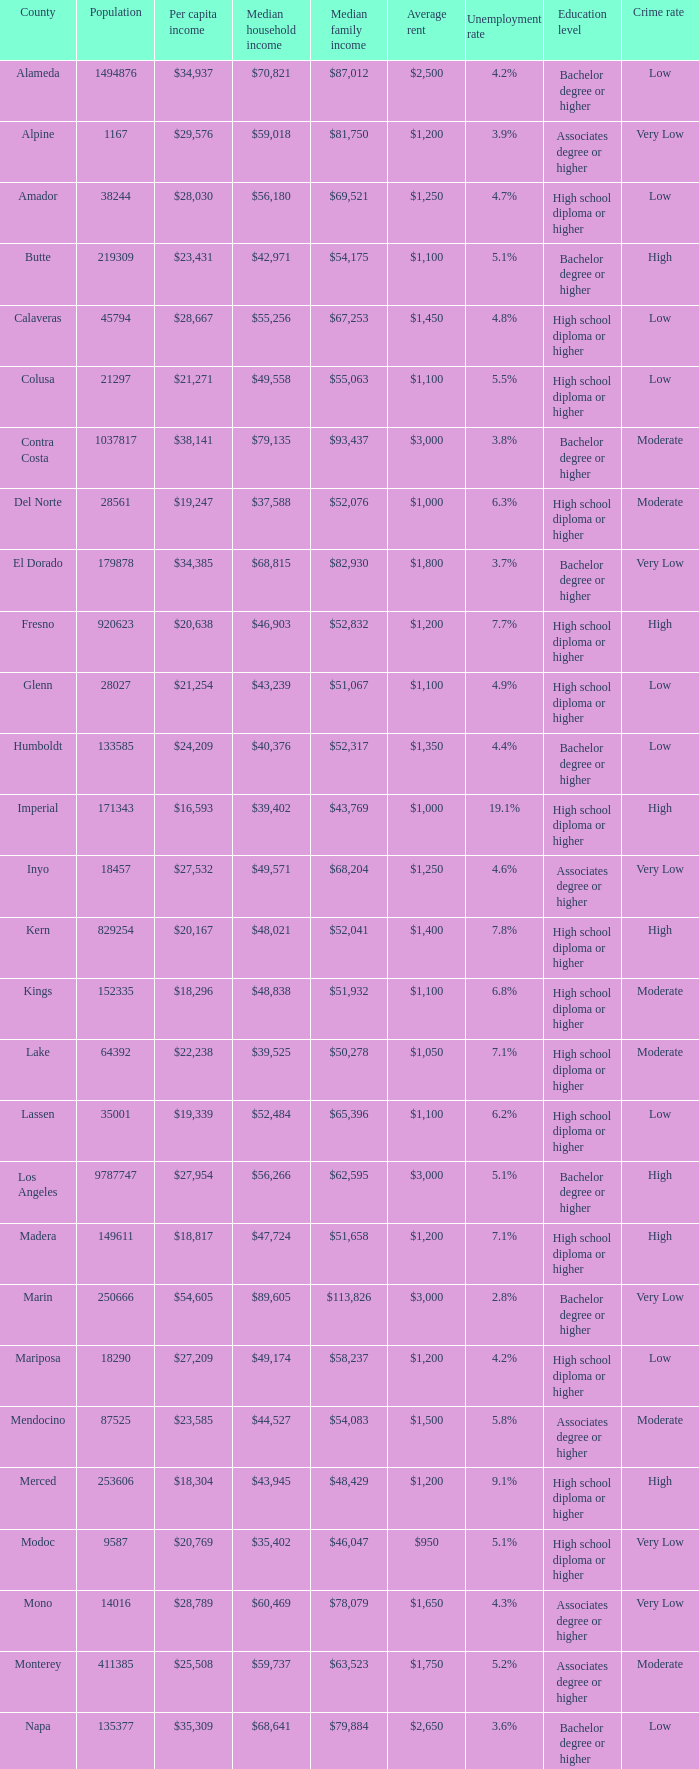Help me parse the entirety of this table. {'header': ['County', 'Population', 'Per capita income', 'Median household income', 'Median family income', 'Average rent', 'Unemployment rate', 'Education level', 'Crime rate '], 'rows': [['Alameda', '1494876', '$34,937', '$70,821', '$87,012', '$2,500', '4.2%', 'Bachelor degree or higher', 'Low'], ['Alpine', '1167', '$29,576', '$59,018', '$81,750', '$1,200', '3.9%', 'Associates degree or higher', 'Very Low'], ['Amador', '38244', '$28,030', '$56,180', '$69,521', '$1,250', '4.7%', 'High school diploma or higher', 'Low'], ['Butte', '219309', '$23,431', '$42,971', '$54,175', '$1,100', '5.1%', 'Bachelor degree or higher', 'High'], ['Calaveras', '45794', '$28,667', '$55,256', '$67,253', '$1,450', '4.8%', 'High school diploma or higher', 'Low'], ['Colusa', '21297', '$21,271', '$49,558', '$55,063', '$1,100', '5.5%', 'High school diploma or higher', 'Low'], ['Contra Costa', '1037817', '$38,141', '$79,135', '$93,437', '$3,000', '3.8%', 'Bachelor degree or higher', 'Moderate'], ['Del Norte', '28561', '$19,247', '$37,588', '$52,076', '$1,000', '6.3%', 'High school diploma or higher', 'Moderate'], ['El Dorado', '179878', '$34,385', '$68,815', '$82,930', '$1,800', '3.7%', 'Bachelor degree or higher', 'Very Low'], ['Fresno', '920623', '$20,638', '$46,903', '$52,832', '$1,200', '7.7%', 'High school diploma or higher', 'High'], ['Glenn', '28027', '$21,254', '$43,239', '$51,067', '$1,100', '4.9%', 'High school diploma or higher', 'Low'], ['Humboldt', '133585', '$24,209', '$40,376', '$52,317', '$1,350', '4.4%', 'Bachelor degree or higher', 'Low'], ['Imperial', '171343', '$16,593', '$39,402', '$43,769', '$1,000', '19.1%', 'High school diploma or higher', 'High'], ['Inyo', '18457', '$27,532', '$49,571', '$68,204', '$1,250', '4.6%', 'Associates degree or higher', 'Very Low'], ['Kern', '829254', '$20,167', '$48,021', '$52,041', '$1,400', '7.8%', 'High school diploma or higher', 'High'], ['Kings', '152335', '$18,296', '$48,838', '$51,932', '$1,100', '6.8%', 'High school diploma or higher', 'Moderate'], ['Lake', '64392', '$22,238', '$39,525', '$50,278', '$1,050', '7.1%', 'High school diploma or higher', 'Moderate'], ['Lassen', '35001', '$19,339', '$52,484', '$65,396', '$1,100', '6.2%', 'High school diploma or higher', 'Low'], ['Los Angeles', '9787747', '$27,954', '$56,266', '$62,595', '$3,000', '5.1%', 'Bachelor degree or higher', 'High'], ['Madera', '149611', '$18,817', '$47,724', '$51,658', '$1,200', '7.1%', 'High school diploma or higher', 'High'], ['Marin', '250666', '$54,605', '$89,605', '$113,826', '$3,000', '2.8%', 'Bachelor degree or higher', 'Very Low'], ['Mariposa', '18290', '$27,209', '$49,174', '$58,237', '$1,200', '4.2%', 'High school diploma or higher', 'Low'], ['Mendocino', '87525', '$23,585', '$44,527', '$54,083', '$1,500', '5.8%', 'Associates degree or higher', 'Moderate'], ['Merced', '253606', '$18,304', '$43,945', '$48,429', '$1,200', '9.1%', 'High school diploma or higher', 'High'], ['Modoc', '9587', '$20,769', '$35,402', '$46,047', '$950', '5.1%', 'High school diploma or higher', 'Very Low'], ['Mono', '14016', '$28,789', '$60,469', '$78,079', '$1,650', '4.3%', 'Associates degree or higher', 'Very Low'], ['Monterey', '411385', '$25,508', '$59,737', '$63,523', '$1,750', '5.2%', 'Associates degree or higher', 'Moderate'], ['Napa', '135377', '$35,309', '$68,641', '$79,884', '$2,650', '3.6%', 'Bachelor degree or higher', 'Low'], ['Nevada', '98392', '$31,607', '$58,077', '$69,807', '$1,450', '4.3%', 'Associates degree or higher', 'Low'], ['Orange', '2989948', '$34,416', '$75,762', '$85,009', '$2,850', '3.2%', 'Bachelor degree or higher', 'Moderate'], ['Placer', '343554', '$35,583', '$74,645', '$90,446', '$2,300', '3.4%', 'Bachelor degree or higher', 'Very Low'], ['Plumas', '20192', '$28,104', '$44,151', '$53,128', '$1,550', '4.5%', 'Associates degree or higher', 'Low'], ['Riverside', '2154844', '$24,516', '$58,365', '$65,457', '$2,000', '5.2%', 'High school diploma or higher', 'High'], ['Sacramento', '1408480', '$27,180', '$56,553', '$65,720', '$1,800', '4.5%', 'Bachelor degree or higher', 'Moderate'], ['San Benito', '54873', '$26,300', '$65,570', '$73,150', '$1,850', '4.1%', 'Associates degree or higher', 'Low'], ['San Bernardino', '2023452', '$21,932', '$55,853', '$61,525', '$1,350', '5.6%', 'High school diploma or higher', 'High'], ['San Diego', '3060849', '$30,955', '$63,857', '$74,633', '$2,750', '3.7%', 'Bachelor degree or higher', 'Moderate'], ['San Francisco', '797983', '$46,777', '$72,947', '$87,329', '$3,750', '2.6%', 'Bachelor degree or higher', 'Very Low'], ['San Joaquin', '680277', '$22,857', '$53,764', '$60,725', '$1,450', '6.0%', 'High school diploma or higher', 'High'], ['San Luis Obispo', '267871', '$30,204', '$58,630', '$74,841', '$1,950', '3.6%', 'Bachelor degree or higher', 'Low'], ['San Mateo', '711622', '$45,346', '$87,633', '$104,370', '$3,250', '3.0%', 'Bachelor degree or higher', 'Very Low'], ['Santa Barbara', '419793', '$30,330', '$61,896', '$71,695', '$2,450', '4.1%', 'Bachelor degree or higher', 'Moderate'], ['Santa Clara', '1762754', '$40,698', '$89,064', '$103,255', '$2,900', '3.3%', 'Bachelor degree or higher', 'Low'], ['Santa Cruz', '259402', '$32,975', '$66,030', '$80,572', '$2,400', '4.2%', 'Bachelor degree or higher', 'Moderate'], ['Shasta', '177231', '$23,691', '$44,058', '$55,250', '$1,250', '5.4%', 'High school diploma or higher', 'High'], ['Sierra', '3277', '$26,137', '$50,308', '$56,469', '$1,300', '4.1%', 'Associates degree or higher', 'Very Low'], ['Siskiyou', '44687', '$22,335', '$37,865', '$47,632', '$1,050', '5.0%', 'High school diploma or higher', 'Moderate'], ['Solano', '411620', '$29,367', '$69,914', '$79,316', '$2,400', '4.2%', 'Associates degree or higher', 'Moderate'], ['Sonoma', '478551', '$33,119', '$64,343', '$78,227', '$2,400', '3.7%', 'Bachelor degree or higher', 'Moderate'], ['Stanislaus', '512469', '$21,820', '$50,671', '$56,996', '$1,350', '7.3%', 'High school diploma or higher', 'High'], ['Sutter', '94192', '$22,464', '$50,010', '$54,737', '$1,200', '4.7%', 'High school diploma or higher', 'Moderate'], ['Tehama', '62985', '$20,689', '$38,753', '$46,805', '$1,100', '6.0%', 'High school diploma or higher', 'High'], ['Trinity', '13711', '$22,551', '$37,672', '$46,980', '$1,100', '4.6%', 'High school diploma or higher', 'Low'], ['Tulare', '436234', '$17,986', '$43,550', '$46,881', '$1,150', '8.0%', 'High school diploma or higher', 'High'], ['Tuolumne', '55736', '$26,084', '$47,359', '$59,710', '$1,450', '5.3%', 'Associates degree or higher', 'Low'], ['Ventura', '815745', '$32,740', '$76,728', '$86,321', '$2,800', '3.6%', 'Bachelor degree or higher', 'Moderate'], ['Yolo', '198889', '$28,631', '$57,920', '$74,991', '$1,850', '4.3%', 'Bachelor degree or higher', 'High']]} What is the per capita income of shasta? $23,691. 